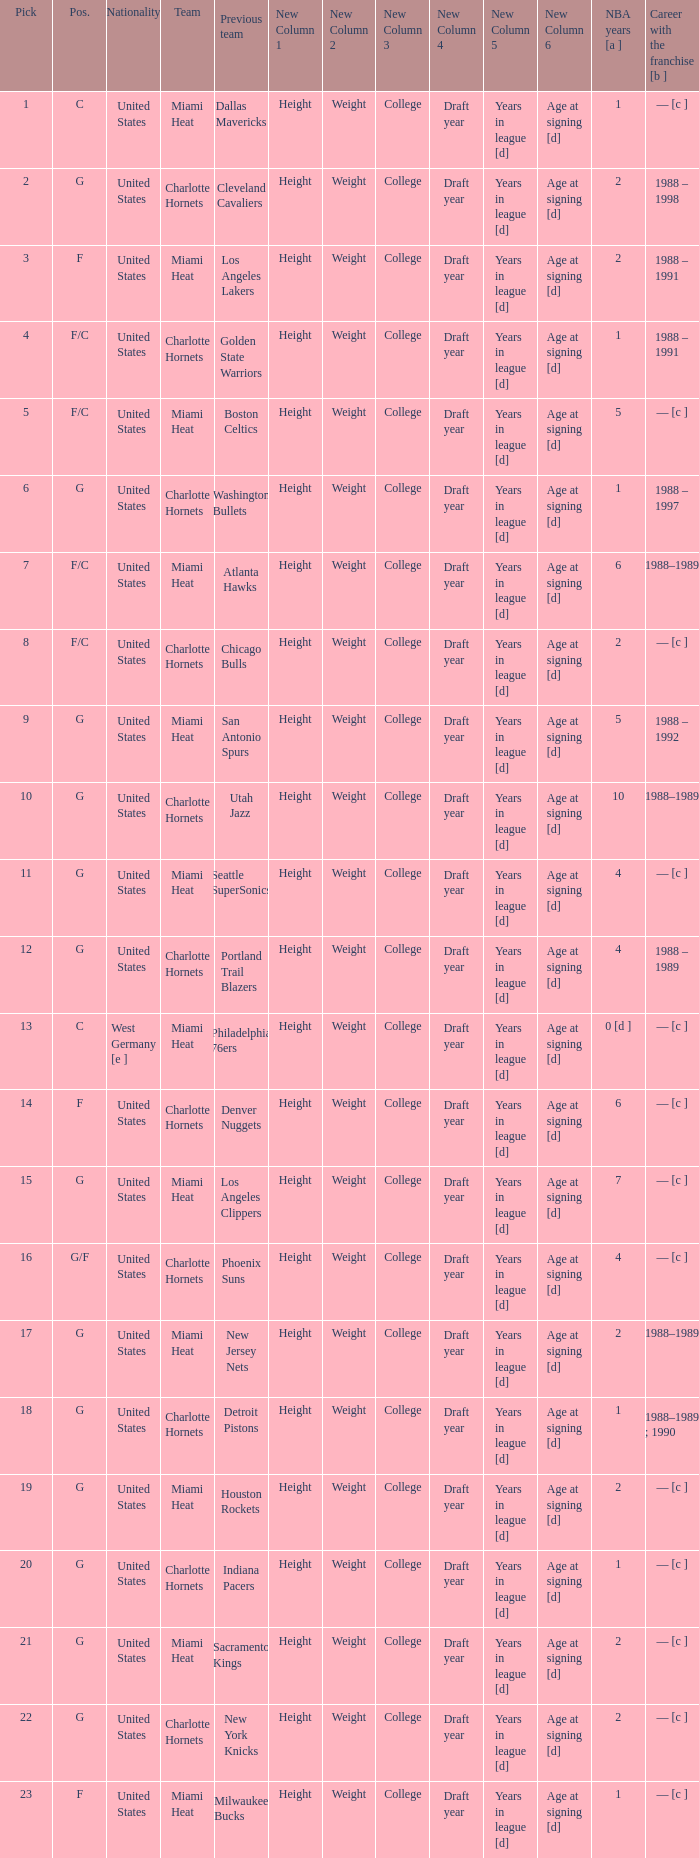Which team did the player with 4 years in the nba and a draft pick under 16 previously belong to? Seattle SuperSonics, Portland Trail Blazers. 